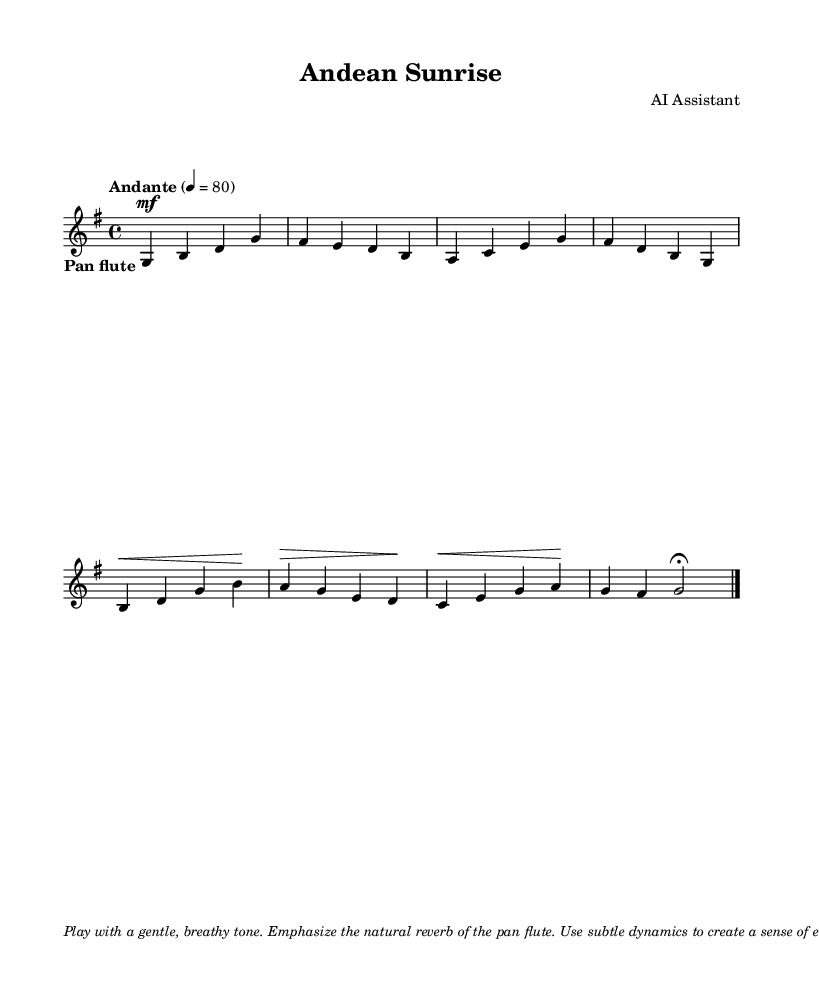What is the key signature of this music? The key signature is indicated by the number of sharps or flats at the beginning of the staff. In this case, the presence of one sharp (F#) shows it is in G major.
Answer: G major What is the time signature of this music? The time signature appears at the beginning of the staff, represented by the numbers above the staff. Here, the time signature is 4/4, meaning there are four beats in each measure.
Answer: 4/4 What is the tempo marking for this piece? The tempo marking is specified by the word "Andante" above the staff, which indicates a moderately slow pace. The numeric value (4 = 80) further confirms the beats per minute.
Answer: Andante, 80 How many measures are in the piece? By counting the distinct groupings of notes separated by bar lines, we can determine the number of measures. This piece has eight measures, as indicated by the structure of the notes and bars.
Answer: 8 What instrument is specified for this score? The instrument is indicated by the line "\set Staff.midiInstrument = "pan flute"" at the beginning of the score. This shows the piece is written for the pan flute.
Answer: pan flute What dynamic indication is present at the beginning of the piece? The dynamic marking "mf" appears under the first measure of the score, indicating that the music should be played at a moderately soft volume.
Answer: mf 